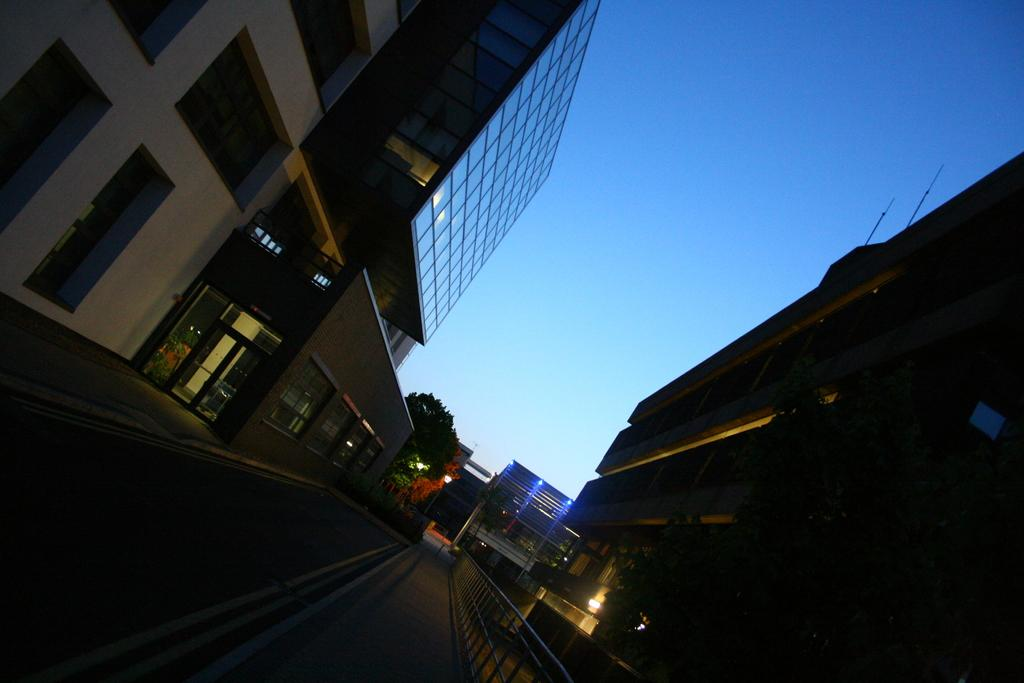What type of structures are present in the image? There are buildings in the image. What colors are the buildings? The buildings are in cream and brown colors. What can be seen in the background of the image? There is a blue color board and trees in the background. What is the color of the sky in the image? The sky is visible in the background and is blue in color. Where is the island mentioned in the image? There is no island present in the image. What type of meeting is taking place in the image? There is no meeting taking place in the image. 